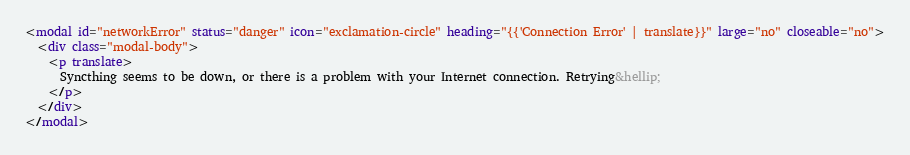Convert code to text. <code><loc_0><loc_0><loc_500><loc_500><_HTML_><modal id="networkError" status="danger" icon="exclamation-circle" heading="{{'Connection Error' | translate}}" large="no" closeable="no">
  <div class="modal-body">
    <p translate>
      Syncthing seems to be down, or there is a problem with your Internet connection. Retrying&hellip;
    </p>
  </div>
</modal>
</code> 